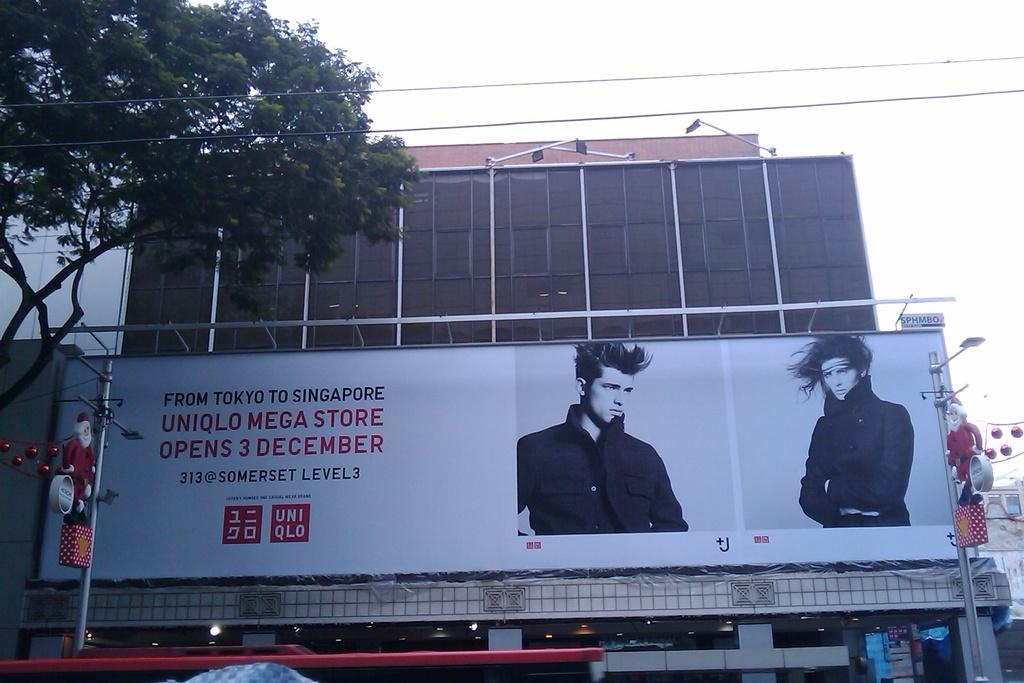<image>
Summarize the visual content of the image. A billboard advertising clothing from Tokyo to Singapore. 